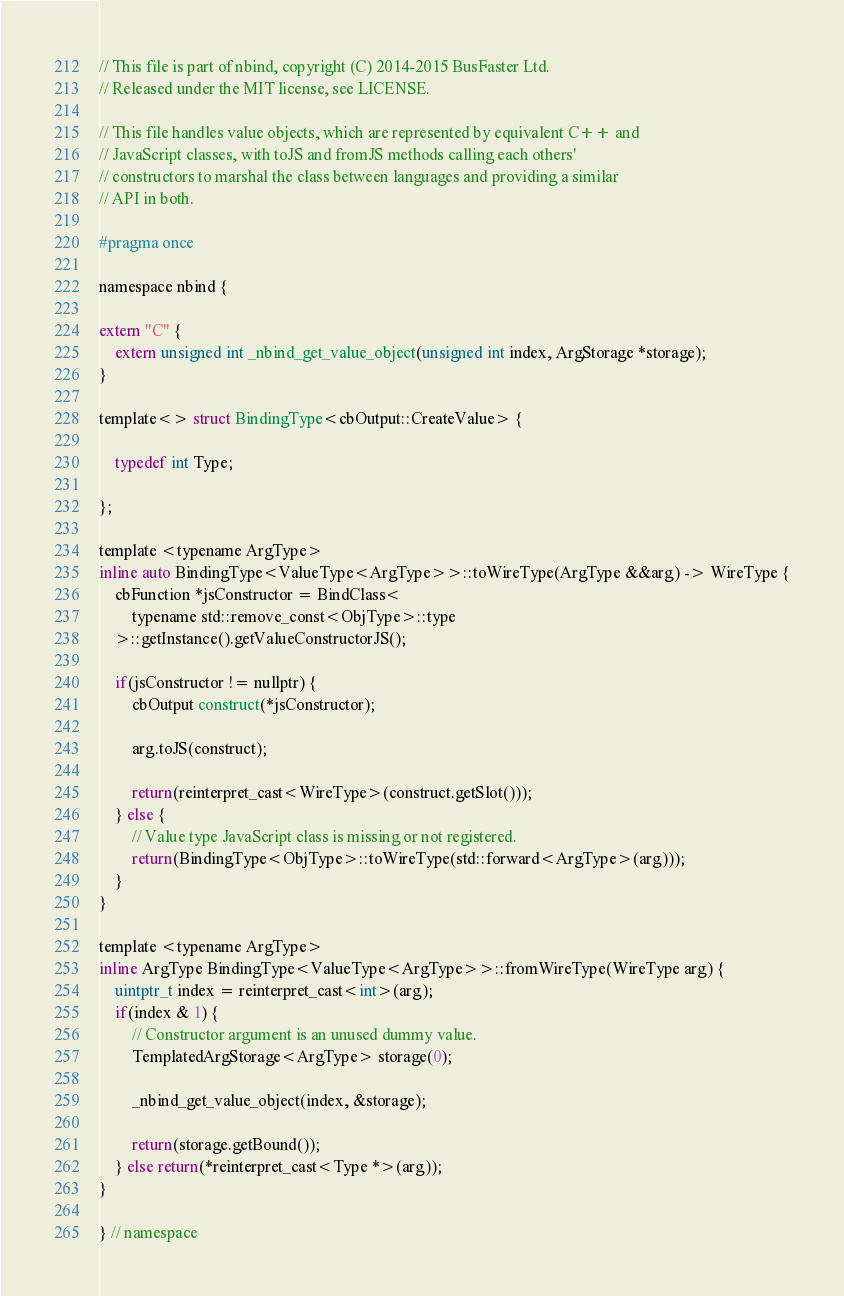Convert code to text. <code><loc_0><loc_0><loc_500><loc_500><_C_>// This file is part of nbind, copyright (C) 2014-2015 BusFaster Ltd.
// Released under the MIT license, see LICENSE.

// This file handles value objects, which are represented by equivalent C++ and
// JavaScript classes, with toJS and fromJS methods calling each others'
// constructors to marshal the class between languages and providing a similar
// API in both.

#pragma once

namespace nbind {

extern "C" {
	extern unsigned int _nbind_get_value_object(unsigned int index, ArgStorage *storage);
}

template<> struct BindingType<cbOutput::CreateValue> {

	typedef int Type;

};

template <typename ArgType>
inline auto BindingType<ValueType<ArgType>>::toWireType(ArgType &&arg) -> WireType {
	cbFunction *jsConstructor = BindClass<
		typename std::remove_const<ObjType>::type
	>::getInstance().getValueConstructorJS();

	if(jsConstructor != nullptr) {
		cbOutput construct(*jsConstructor);

		arg.toJS(construct);

		return(reinterpret_cast<WireType>(construct.getSlot()));
	} else {
		// Value type JavaScript class is missing or not registered.
		return(BindingType<ObjType>::toWireType(std::forward<ArgType>(arg)));
	}
}

template <typename ArgType>
inline ArgType BindingType<ValueType<ArgType>>::fromWireType(WireType arg) {
	uintptr_t index = reinterpret_cast<int>(arg);
	if(index & 1) {
		// Constructor argument is an unused dummy value.
		TemplatedArgStorage<ArgType> storage(0);

		_nbind_get_value_object(index, &storage);

		return(storage.getBound());
	} else return(*reinterpret_cast<Type *>(arg));
}

} // namespace
</code> 